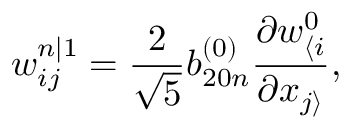Convert formula to latex. <formula><loc_0><loc_0><loc_500><loc_500>w _ { i j } ^ { n | 1 } = \frac { 2 } { \sqrt { 5 } } b _ { 2 0 n } ^ { ( 0 ) } \frac { \partial w _ { \langle i } ^ { 0 } } { \partial x _ { j \rangle } } ,</formula> 